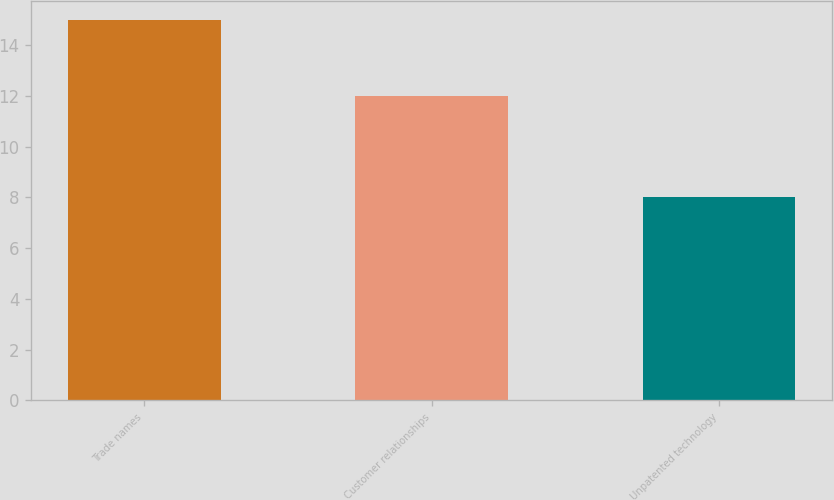Convert chart to OTSL. <chart><loc_0><loc_0><loc_500><loc_500><bar_chart><fcel>Trade names<fcel>Customer relationships<fcel>Unpatented technology<nl><fcel>15<fcel>12<fcel>8<nl></chart> 